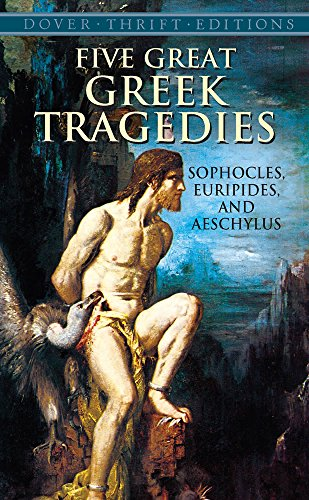Who wrote this book?
Answer the question using a single word or phrase. Sophocles What is the title of this book? Five Great Greek Tragedies (Dover Thrift Editions) What type of book is this? Literature & Fiction Is this a recipe book? No 